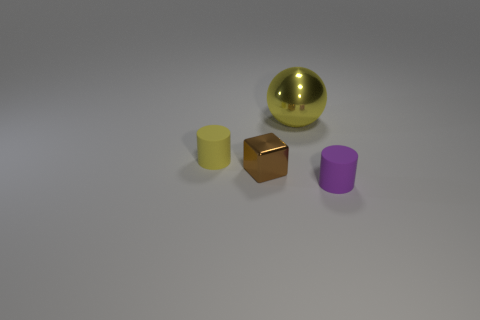What number of blocks are either tiny brown rubber things or yellow rubber objects?
Offer a terse response. 0. What number of things are in front of the yellow matte thing and behind the small yellow cylinder?
Offer a very short reply. 0. Is the size of the yellow sphere the same as the cylinder on the right side of the big sphere?
Make the answer very short. No. There is a tiny rubber cylinder that is behind the small matte cylinder that is on the right side of the large yellow ball; are there any large yellow metallic objects in front of it?
Your response must be concise. No. The yellow thing behind the cylinder on the left side of the large yellow sphere is made of what material?
Provide a succinct answer. Metal. The object that is both to the left of the purple cylinder and on the right side of the brown cube is made of what material?
Offer a very short reply. Metal. Is there a green shiny thing of the same shape as the brown object?
Your answer should be very brief. No. Are there any yellow cylinders behind the yellow thing behind the small yellow rubber object?
Offer a terse response. No. What number of tiny yellow balls are made of the same material as the brown thing?
Keep it short and to the point. 0. Are any yellow rubber objects visible?
Ensure brevity in your answer.  Yes. 